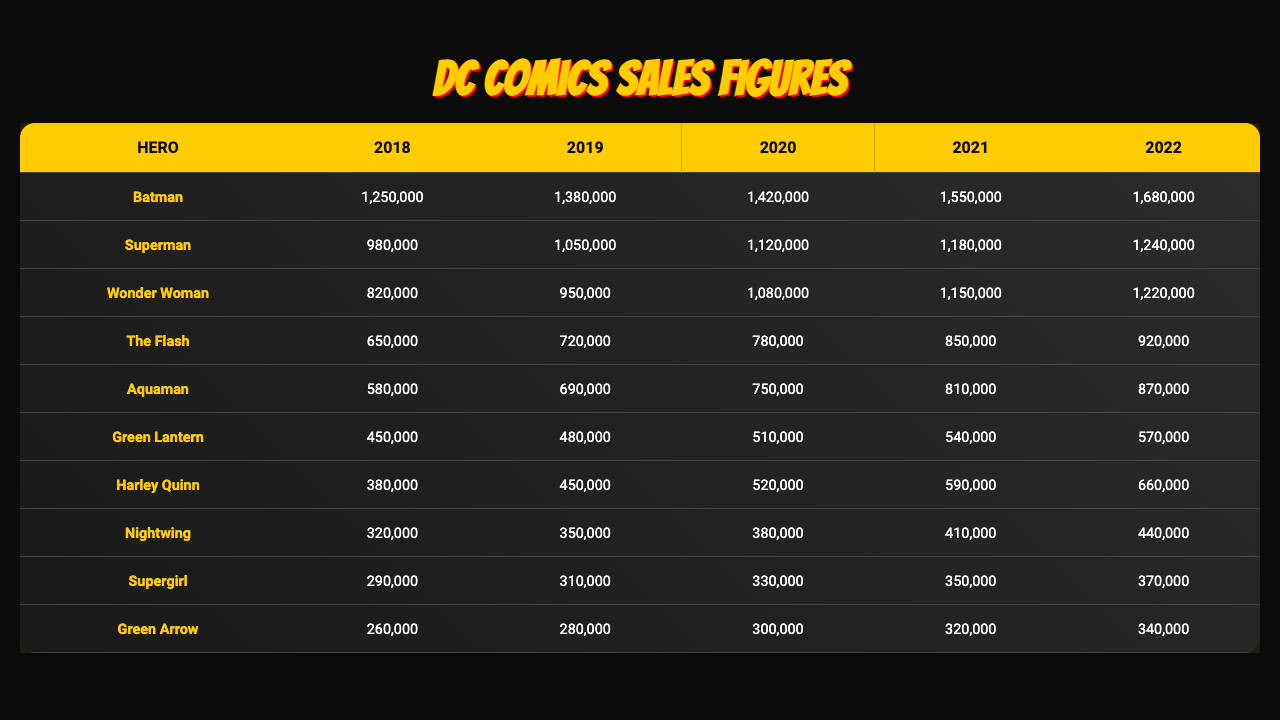What was the sales figure for Batman in 2022? Referring to the table, the sales figure for Batman in 2022 is listed directly under the year column for 2022.
Answer: 1,680,000 Which superhero had the highest sales in 2020? By comparing the sales figures for all superheroes in 2020, Batman has the highest sales at 1,420,000.
Answer: Batman What is the total sales figure for Wonder Woman from 2018 to 2022? To find the total, add the sales for Wonder Woman over the five years: (820,000 + 950,000 + 1,080,000 + 1,150,000 + 1,220,000) = 4,220,000.
Answer: 4,220,000 Did Harley Quinn's sales increase every year from 2018 to 2022? By examining the sales figures year over year for Harley Quinn, it is clear that the sales figures consistently rose each year, indicating an increase every year.
Answer: Yes What is the average sales figure for The Flash from 2018 to 2022? Add the sales figures for The Flash: (650,000 + 720,000 + 780,000 + 850,000 + 920,000) = 3,920,000, then divide by 5 (the number of years): 3,920,000 / 5 = 784,000.
Answer: 784,000 Which superhero had the lowest sales in 2019? By reviewing the sales figures for all superheroes in 2019, Green Arrow has the lowest sales with 280,000.
Answer: Green Arrow What is the difference in sales figures between Aquaman in 2018 and in 2022? Find the sales figures for Aquaman for both years: 580,000 in 2018 and 870,000 in 2022. The difference is 870,000 - 580,000 = 290,000.
Answer: 290,000 In which year did Supergirl achieve sales of 350,000? Directly looking at the sales figures for Supergirl in the table, the figure of 350,000 appears in the year 2021.
Answer: 2021 Which superhero showed the least consistent growth over the 5 years? By analyzing the growth percentages of each superhero, Green Lantern demonstrated the least consistent growth rate compared to the others over the 5 years.
Answer: Green Lantern What is the combined sales figure of Superman and Nightwing for 2021? Add the sales figures for both Superman (1,180,000) and Nightwing (410,000) for 2021, resulting in a total of 1,180,000 + 410,000 = 1,590,000.
Answer: 1,590,000 